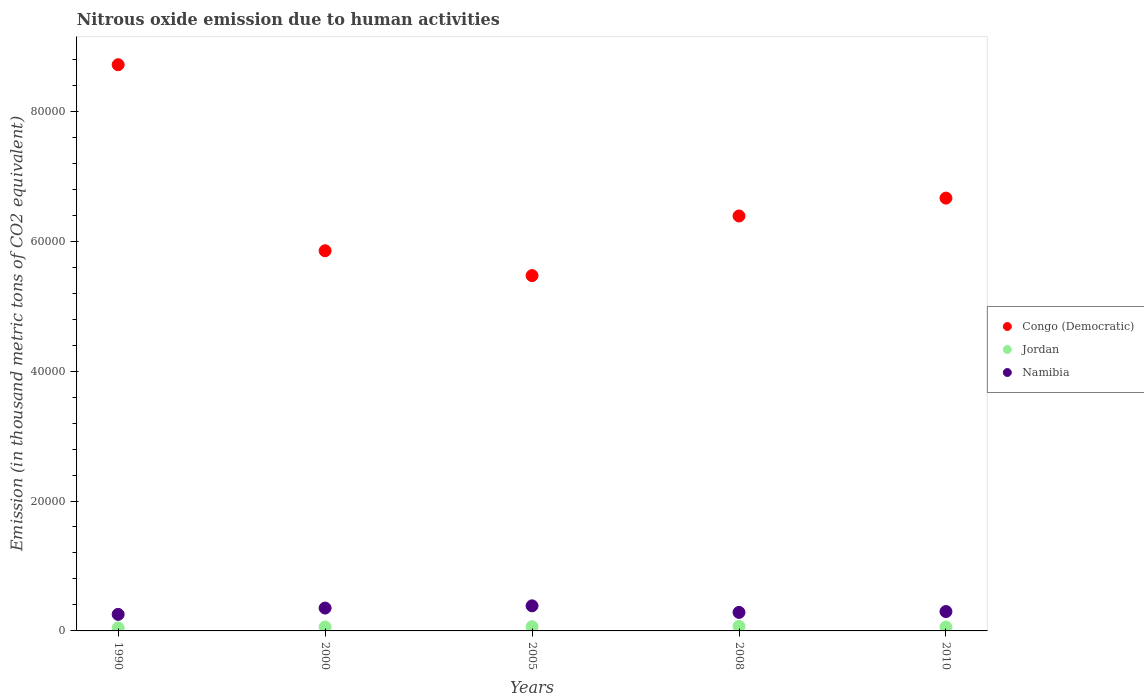Is the number of dotlines equal to the number of legend labels?
Offer a terse response. Yes. What is the amount of nitrous oxide emitted in Congo (Democratic) in 2008?
Ensure brevity in your answer.  6.39e+04. Across all years, what is the maximum amount of nitrous oxide emitted in Congo (Democratic)?
Offer a very short reply. 8.72e+04. Across all years, what is the minimum amount of nitrous oxide emitted in Namibia?
Offer a very short reply. 2547.1. In which year was the amount of nitrous oxide emitted in Namibia maximum?
Provide a short and direct response. 2005. In which year was the amount of nitrous oxide emitted in Congo (Democratic) minimum?
Offer a very short reply. 2005. What is the total amount of nitrous oxide emitted in Congo (Democratic) in the graph?
Offer a terse response. 3.31e+05. What is the difference between the amount of nitrous oxide emitted in Jordan in 1990 and that in 2008?
Offer a terse response. -231.1. What is the difference between the amount of nitrous oxide emitted in Namibia in 2008 and the amount of nitrous oxide emitted in Congo (Democratic) in 2010?
Offer a very short reply. -6.38e+04. What is the average amount of nitrous oxide emitted in Congo (Democratic) per year?
Give a very brief answer. 6.62e+04. In the year 2008, what is the difference between the amount of nitrous oxide emitted in Congo (Democratic) and amount of nitrous oxide emitted in Namibia?
Provide a short and direct response. 6.10e+04. What is the ratio of the amount of nitrous oxide emitted in Congo (Democratic) in 1990 to that in 2008?
Keep it short and to the point. 1.36. Is the amount of nitrous oxide emitted in Namibia in 2005 less than that in 2010?
Your response must be concise. No. Is the difference between the amount of nitrous oxide emitted in Congo (Democratic) in 1990 and 2000 greater than the difference between the amount of nitrous oxide emitted in Namibia in 1990 and 2000?
Your answer should be very brief. Yes. What is the difference between the highest and the second highest amount of nitrous oxide emitted in Jordan?
Ensure brevity in your answer.  43.9. What is the difference between the highest and the lowest amount of nitrous oxide emitted in Namibia?
Your answer should be very brief. 1314.1. In how many years, is the amount of nitrous oxide emitted in Congo (Democratic) greater than the average amount of nitrous oxide emitted in Congo (Democratic) taken over all years?
Your answer should be compact. 2. Is the sum of the amount of nitrous oxide emitted in Jordan in 2005 and 2010 greater than the maximum amount of nitrous oxide emitted in Namibia across all years?
Ensure brevity in your answer.  No. Does the amount of nitrous oxide emitted in Namibia monotonically increase over the years?
Keep it short and to the point. No. Is the amount of nitrous oxide emitted in Jordan strictly less than the amount of nitrous oxide emitted in Congo (Democratic) over the years?
Provide a short and direct response. Yes. How many dotlines are there?
Offer a very short reply. 3. How many years are there in the graph?
Ensure brevity in your answer.  5. What is the difference between two consecutive major ticks on the Y-axis?
Offer a very short reply. 2.00e+04. Does the graph contain any zero values?
Offer a very short reply. No. How many legend labels are there?
Provide a succinct answer. 3. How are the legend labels stacked?
Provide a succinct answer. Vertical. What is the title of the graph?
Make the answer very short. Nitrous oxide emission due to human activities. Does "Montenegro" appear as one of the legend labels in the graph?
Offer a terse response. No. What is the label or title of the X-axis?
Give a very brief answer. Years. What is the label or title of the Y-axis?
Offer a terse response. Emission (in thousand metric tons of CO2 equivalent). What is the Emission (in thousand metric tons of CO2 equivalent) in Congo (Democratic) in 1990?
Provide a short and direct response. 8.72e+04. What is the Emission (in thousand metric tons of CO2 equivalent) of Jordan in 1990?
Your answer should be compact. 463.8. What is the Emission (in thousand metric tons of CO2 equivalent) of Namibia in 1990?
Your answer should be compact. 2547.1. What is the Emission (in thousand metric tons of CO2 equivalent) in Congo (Democratic) in 2000?
Provide a succinct answer. 5.85e+04. What is the Emission (in thousand metric tons of CO2 equivalent) in Jordan in 2000?
Your answer should be very brief. 606.8. What is the Emission (in thousand metric tons of CO2 equivalent) of Namibia in 2000?
Offer a very short reply. 3518.5. What is the Emission (in thousand metric tons of CO2 equivalent) in Congo (Democratic) in 2005?
Ensure brevity in your answer.  5.47e+04. What is the Emission (in thousand metric tons of CO2 equivalent) in Jordan in 2005?
Make the answer very short. 651. What is the Emission (in thousand metric tons of CO2 equivalent) in Namibia in 2005?
Make the answer very short. 3861.2. What is the Emission (in thousand metric tons of CO2 equivalent) in Congo (Democratic) in 2008?
Your response must be concise. 6.39e+04. What is the Emission (in thousand metric tons of CO2 equivalent) of Jordan in 2008?
Your answer should be very brief. 694.9. What is the Emission (in thousand metric tons of CO2 equivalent) in Namibia in 2008?
Ensure brevity in your answer.  2851.2. What is the Emission (in thousand metric tons of CO2 equivalent) of Congo (Democratic) in 2010?
Your answer should be compact. 6.66e+04. What is the Emission (in thousand metric tons of CO2 equivalent) in Jordan in 2010?
Your response must be concise. 592.7. What is the Emission (in thousand metric tons of CO2 equivalent) of Namibia in 2010?
Make the answer very short. 2982.6. Across all years, what is the maximum Emission (in thousand metric tons of CO2 equivalent) in Congo (Democratic)?
Your answer should be compact. 8.72e+04. Across all years, what is the maximum Emission (in thousand metric tons of CO2 equivalent) in Jordan?
Give a very brief answer. 694.9. Across all years, what is the maximum Emission (in thousand metric tons of CO2 equivalent) in Namibia?
Provide a succinct answer. 3861.2. Across all years, what is the minimum Emission (in thousand metric tons of CO2 equivalent) of Congo (Democratic)?
Keep it short and to the point. 5.47e+04. Across all years, what is the minimum Emission (in thousand metric tons of CO2 equivalent) in Jordan?
Make the answer very short. 463.8. Across all years, what is the minimum Emission (in thousand metric tons of CO2 equivalent) in Namibia?
Ensure brevity in your answer.  2547.1. What is the total Emission (in thousand metric tons of CO2 equivalent) of Congo (Democratic) in the graph?
Offer a very short reply. 3.31e+05. What is the total Emission (in thousand metric tons of CO2 equivalent) in Jordan in the graph?
Your answer should be compact. 3009.2. What is the total Emission (in thousand metric tons of CO2 equivalent) in Namibia in the graph?
Offer a terse response. 1.58e+04. What is the difference between the Emission (in thousand metric tons of CO2 equivalent) of Congo (Democratic) in 1990 and that in 2000?
Offer a very short reply. 2.86e+04. What is the difference between the Emission (in thousand metric tons of CO2 equivalent) of Jordan in 1990 and that in 2000?
Your answer should be very brief. -143. What is the difference between the Emission (in thousand metric tons of CO2 equivalent) in Namibia in 1990 and that in 2000?
Offer a very short reply. -971.4. What is the difference between the Emission (in thousand metric tons of CO2 equivalent) of Congo (Democratic) in 1990 and that in 2005?
Provide a succinct answer. 3.25e+04. What is the difference between the Emission (in thousand metric tons of CO2 equivalent) in Jordan in 1990 and that in 2005?
Offer a very short reply. -187.2. What is the difference between the Emission (in thousand metric tons of CO2 equivalent) in Namibia in 1990 and that in 2005?
Your answer should be very brief. -1314.1. What is the difference between the Emission (in thousand metric tons of CO2 equivalent) of Congo (Democratic) in 1990 and that in 2008?
Ensure brevity in your answer.  2.33e+04. What is the difference between the Emission (in thousand metric tons of CO2 equivalent) of Jordan in 1990 and that in 2008?
Keep it short and to the point. -231.1. What is the difference between the Emission (in thousand metric tons of CO2 equivalent) of Namibia in 1990 and that in 2008?
Give a very brief answer. -304.1. What is the difference between the Emission (in thousand metric tons of CO2 equivalent) of Congo (Democratic) in 1990 and that in 2010?
Your answer should be compact. 2.05e+04. What is the difference between the Emission (in thousand metric tons of CO2 equivalent) in Jordan in 1990 and that in 2010?
Your response must be concise. -128.9. What is the difference between the Emission (in thousand metric tons of CO2 equivalent) of Namibia in 1990 and that in 2010?
Give a very brief answer. -435.5. What is the difference between the Emission (in thousand metric tons of CO2 equivalent) of Congo (Democratic) in 2000 and that in 2005?
Ensure brevity in your answer.  3826.5. What is the difference between the Emission (in thousand metric tons of CO2 equivalent) in Jordan in 2000 and that in 2005?
Make the answer very short. -44.2. What is the difference between the Emission (in thousand metric tons of CO2 equivalent) in Namibia in 2000 and that in 2005?
Provide a short and direct response. -342.7. What is the difference between the Emission (in thousand metric tons of CO2 equivalent) in Congo (Democratic) in 2000 and that in 2008?
Your response must be concise. -5353.8. What is the difference between the Emission (in thousand metric tons of CO2 equivalent) in Jordan in 2000 and that in 2008?
Provide a short and direct response. -88.1. What is the difference between the Emission (in thousand metric tons of CO2 equivalent) of Namibia in 2000 and that in 2008?
Provide a short and direct response. 667.3. What is the difference between the Emission (in thousand metric tons of CO2 equivalent) in Congo (Democratic) in 2000 and that in 2010?
Make the answer very short. -8104.1. What is the difference between the Emission (in thousand metric tons of CO2 equivalent) of Jordan in 2000 and that in 2010?
Ensure brevity in your answer.  14.1. What is the difference between the Emission (in thousand metric tons of CO2 equivalent) in Namibia in 2000 and that in 2010?
Offer a terse response. 535.9. What is the difference between the Emission (in thousand metric tons of CO2 equivalent) in Congo (Democratic) in 2005 and that in 2008?
Your response must be concise. -9180.3. What is the difference between the Emission (in thousand metric tons of CO2 equivalent) of Jordan in 2005 and that in 2008?
Ensure brevity in your answer.  -43.9. What is the difference between the Emission (in thousand metric tons of CO2 equivalent) of Namibia in 2005 and that in 2008?
Your answer should be compact. 1010. What is the difference between the Emission (in thousand metric tons of CO2 equivalent) of Congo (Democratic) in 2005 and that in 2010?
Keep it short and to the point. -1.19e+04. What is the difference between the Emission (in thousand metric tons of CO2 equivalent) in Jordan in 2005 and that in 2010?
Ensure brevity in your answer.  58.3. What is the difference between the Emission (in thousand metric tons of CO2 equivalent) in Namibia in 2005 and that in 2010?
Provide a succinct answer. 878.6. What is the difference between the Emission (in thousand metric tons of CO2 equivalent) in Congo (Democratic) in 2008 and that in 2010?
Provide a short and direct response. -2750.3. What is the difference between the Emission (in thousand metric tons of CO2 equivalent) in Jordan in 2008 and that in 2010?
Your answer should be compact. 102.2. What is the difference between the Emission (in thousand metric tons of CO2 equivalent) of Namibia in 2008 and that in 2010?
Your response must be concise. -131.4. What is the difference between the Emission (in thousand metric tons of CO2 equivalent) in Congo (Democratic) in 1990 and the Emission (in thousand metric tons of CO2 equivalent) in Jordan in 2000?
Your answer should be compact. 8.66e+04. What is the difference between the Emission (in thousand metric tons of CO2 equivalent) in Congo (Democratic) in 1990 and the Emission (in thousand metric tons of CO2 equivalent) in Namibia in 2000?
Ensure brevity in your answer.  8.36e+04. What is the difference between the Emission (in thousand metric tons of CO2 equivalent) of Jordan in 1990 and the Emission (in thousand metric tons of CO2 equivalent) of Namibia in 2000?
Make the answer very short. -3054.7. What is the difference between the Emission (in thousand metric tons of CO2 equivalent) in Congo (Democratic) in 1990 and the Emission (in thousand metric tons of CO2 equivalent) in Jordan in 2005?
Your answer should be very brief. 8.65e+04. What is the difference between the Emission (in thousand metric tons of CO2 equivalent) of Congo (Democratic) in 1990 and the Emission (in thousand metric tons of CO2 equivalent) of Namibia in 2005?
Ensure brevity in your answer.  8.33e+04. What is the difference between the Emission (in thousand metric tons of CO2 equivalent) in Jordan in 1990 and the Emission (in thousand metric tons of CO2 equivalent) in Namibia in 2005?
Offer a terse response. -3397.4. What is the difference between the Emission (in thousand metric tons of CO2 equivalent) in Congo (Democratic) in 1990 and the Emission (in thousand metric tons of CO2 equivalent) in Jordan in 2008?
Give a very brief answer. 8.65e+04. What is the difference between the Emission (in thousand metric tons of CO2 equivalent) of Congo (Democratic) in 1990 and the Emission (in thousand metric tons of CO2 equivalent) of Namibia in 2008?
Your answer should be very brief. 8.43e+04. What is the difference between the Emission (in thousand metric tons of CO2 equivalent) of Jordan in 1990 and the Emission (in thousand metric tons of CO2 equivalent) of Namibia in 2008?
Keep it short and to the point. -2387.4. What is the difference between the Emission (in thousand metric tons of CO2 equivalent) of Congo (Democratic) in 1990 and the Emission (in thousand metric tons of CO2 equivalent) of Jordan in 2010?
Offer a very short reply. 8.66e+04. What is the difference between the Emission (in thousand metric tons of CO2 equivalent) of Congo (Democratic) in 1990 and the Emission (in thousand metric tons of CO2 equivalent) of Namibia in 2010?
Your answer should be very brief. 8.42e+04. What is the difference between the Emission (in thousand metric tons of CO2 equivalent) of Jordan in 1990 and the Emission (in thousand metric tons of CO2 equivalent) of Namibia in 2010?
Make the answer very short. -2518.8. What is the difference between the Emission (in thousand metric tons of CO2 equivalent) of Congo (Democratic) in 2000 and the Emission (in thousand metric tons of CO2 equivalent) of Jordan in 2005?
Offer a terse response. 5.79e+04. What is the difference between the Emission (in thousand metric tons of CO2 equivalent) in Congo (Democratic) in 2000 and the Emission (in thousand metric tons of CO2 equivalent) in Namibia in 2005?
Provide a short and direct response. 5.47e+04. What is the difference between the Emission (in thousand metric tons of CO2 equivalent) of Jordan in 2000 and the Emission (in thousand metric tons of CO2 equivalent) of Namibia in 2005?
Your answer should be very brief. -3254.4. What is the difference between the Emission (in thousand metric tons of CO2 equivalent) in Congo (Democratic) in 2000 and the Emission (in thousand metric tons of CO2 equivalent) in Jordan in 2008?
Ensure brevity in your answer.  5.78e+04. What is the difference between the Emission (in thousand metric tons of CO2 equivalent) of Congo (Democratic) in 2000 and the Emission (in thousand metric tons of CO2 equivalent) of Namibia in 2008?
Ensure brevity in your answer.  5.57e+04. What is the difference between the Emission (in thousand metric tons of CO2 equivalent) of Jordan in 2000 and the Emission (in thousand metric tons of CO2 equivalent) of Namibia in 2008?
Your response must be concise. -2244.4. What is the difference between the Emission (in thousand metric tons of CO2 equivalent) of Congo (Democratic) in 2000 and the Emission (in thousand metric tons of CO2 equivalent) of Jordan in 2010?
Your response must be concise. 5.79e+04. What is the difference between the Emission (in thousand metric tons of CO2 equivalent) of Congo (Democratic) in 2000 and the Emission (in thousand metric tons of CO2 equivalent) of Namibia in 2010?
Ensure brevity in your answer.  5.55e+04. What is the difference between the Emission (in thousand metric tons of CO2 equivalent) of Jordan in 2000 and the Emission (in thousand metric tons of CO2 equivalent) of Namibia in 2010?
Your answer should be very brief. -2375.8. What is the difference between the Emission (in thousand metric tons of CO2 equivalent) in Congo (Democratic) in 2005 and the Emission (in thousand metric tons of CO2 equivalent) in Jordan in 2008?
Ensure brevity in your answer.  5.40e+04. What is the difference between the Emission (in thousand metric tons of CO2 equivalent) of Congo (Democratic) in 2005 and the Emission (in thousand metric tons of CO2 equivalent) of Namibia in 2008?
Keep it short and to the point. 5.19e+04. What is the difference between the Emission (in thousand metric tons of CO2 equivalent) in Jordan in 2005 and the Emission (in thousand metric tons of CO2 equivalent) in Namibia in 2008?
Make the answer very short. -2200.2. What is the difference between the Emission (in thousand metric tons of CO2 equivalent) in Congo (Democratic) in 2005 and the Emission (in thousand metric tons of CO2 equivalent) in Jordan in 2010?
Give a very brief answer. 5.41e+04. What is the difference between the Emission (in thousand metric tons of CO2 equivalent) of Congo (Democratic) in 2005 and the Emission (in thousand metric tons of CO2 equivalent) of Namibia in 2010?
Your answer should be very brief. 5.17e+04. What is the difference between the Emission (in thousand metric tons of CO2 equivalent) of Jordan in 2005 and the Emission (in thousand metric tons of CO2 equivalent) of Namibia in 2010?
Keep it short and to the point. -2331.6. What is the difference between the Emission (in thousand metric tons of CO2 equivalent) of Congo (Democratic) in 2008 and the Emission (in thousand metric tons of CO2 equivalent) of Jordan in 2010?
Your response must be concise. 6.33e+04. What is the difference between the Emission (in thousand metric tons of CO2 equivalent) in Congo (Democratic) in 2008 and the Emission (in thousand metric tons of CO2 equivalent) in Namibia in 2010?
Offer a terse response. 6.09e+04. What is the difference between the Emission (in thousand metric tons of CO2 equivalent) of Jordan in 2008 and the Emission (in thousand metric tons of CO2 equivalent) of Namibia in 2010?
Make the answer very short. -2287.7. What is the average Emission (in thousand metric tons of CO2 equivalent) of Congo (Democratic) per year?
Provide a short and direct response. 6.62e+04. What is the average Emission (in thousand metric tons of CO2 equivalent) of Jordan per year?
Your response must be concise. 601.84. What is the average Emission (in thousand metric tons of CO2 equivalent) of Namibia per year?
Provide a succinct answer. 3152.12. In the year 1990, what is the difference between the Emission (in thousand metric tons of CO2 equivalent) in Congo (Democratic) and Emission (in thousand metric tons of CO2 equivalent) in Jordan?
Your response must be concise. 8.67e+04. In the year 1990, what is the difference between the Emission (in thousand metric tons of CO2 equivalent) in Congo (Democratic) and Emission (in thousand metric tons of CO2 equivalent) in Namibia?
Keep it short and to the point. 8.46e+04. In the year 1990, what is the difference between the Emission (in thousand metric tons of CO2 equivalent) of Jordan and Emission (in thousand metric tons of CO2 equivalent) of Namibia?
Your answer should be compact. -2083.3. In the year 2000, what is the difference between the Emission (in thousand metric tons of CO2 equivalent) in Congo (Democratic) and Emission (in thousand metric tons of CO2 equivalent) in Jordan?
Offer a terse response. 5.79e+04. In the year 2000, what is the difference between the Emission (in thousand metric tons of CO2 equivalent) of Congo (Democratic) and Emission (in thousand metric tons of CO2 equivalent) of Namibia?
Ensure brevity in your answer.  5.50e+04. In the year 2000, what is the difference between the Emission (in thousand metric tons of CO2 equivalent) of Jordan and Emission (in thousand metric tons of CO2 equivalent) of Namibia?
Your answer should be very brief. -2911.7. In the year 2005, what is the difference between the Emission (in thousand metric tons of CO2 equivalent) of Congo (Democratic) and Emission (in thousand metric tons of CO2 equivalent) of Jordan?
Your answer should be compact. 5.41e+04. In the year 2005, what is the difference between the Emission (in thousand metric tons of CO2 equivalent) of Congo (Democratic) and Emission (in thousand metric tons of CO2 equivalent) of Namibia?
Your response must be concise. 5.08e+04. In the year 2005, what is the difference between the Emission (in thousand metric tons of CO2 equivalent) in Jordan and Emission (in thousand metric tons of CO2 equivalent) in Namibia?
Keep it short and to the point. -3210.2. In the year 2008, what is the difference between the Emission (in thousand metric tons of CO2 equivalent) of Congo (Democratic) and Emission (in thousand metric tons of CO2 equivalent) of Jordan?
Your answer should be compact. 6.32e+04. In the year 2008, what is the difference between the Emission (in thousand metric tons of CO2 equivalent) in Congo (Democratic) and Emission (in thousand metric tons of CO2 equivalent) in Namibia?
Make the answer very short. 6.10e+04. In the year 2008, what is the difference between the Emission (in thousand metric tons of CO2 equivalent) in Jordan and Emission (in thousand metric tons of CO2 equivalent) in Namibia?
Your response must be concise. -2156.3. In the year 2010, what is the difference between the Emission (in thousand metric tons of CO2 equivalent) of Congo (Democratic) and Emission (in thousand metric tons of CO2 equivalent) of Jordan?
Your answer should be compact. 6.60e+04. In the year 2010, what is the difference between the Emission (in thousand metric tons of CO2 equivalent) in Congo (Democratic) and Emission (in thousand metric tons of CO2 equivalent) in Namibia?
Make the answer very short. 6.36e+04. In the year 2010, what is the difference between the Emission (in thousand metric tons of CO2 equivalent) of Jordan and Emission (in thousand metric tons of CO2 equivalent) of Namibia?
Make the answer very short. -2389.9. What is the ratio of the Emission (in thousand metric tons of CO2 equivalent) in Congo (Democratic) in 1990 to that in 2000?
Offer a terse response. 1.49. What is the ratio of the Emission (in thousand metric tons of CO2 equivalent) of Jordan in 1990 to that in 2000?
Provide a succinct answer. 0.76. What is the ratio of the Emission (in thousand metric tons of CO2 equivalent) of Namibia in 1990 to that in 2000?
Your response must be concise. 0.72. What is the ratio of the Emission (in thousand metric tons of CO2 equivalent) in Congo (Democratic) in 1990 to that in 2005?
Provide a short and direct response. 1.59. What is the ratio of the Emission (in thousand metric tons of CO2 equivalent) in Jordan in 1990 to that in 2005?
Ensure brevity in your answer.  0.71. What is the ratio of the Emission (in thousand metric tons of CO2 equivalent) of Namibia in 1990 to that in 2005?
Your answer should be very brief. 0.66. What is the ratio of the Emission (in thousand metric tons of CO2 equivalent) of Congo (Democratic) in 1990 to that in 2008?
Offer a terse response. 1.36. What is the ratio of the Emission (in thousand metric tons of CO2 equivalent) in Jordan in 1990 to that in 2008?
Your answer should be very brief. 0.67. What is the ratio of the Emission (in thousand metric tons of CO2 equivalent) in Namibia in 1990 to that in 2008?
Offer a terse response. 0.89. What is the ratio of the Emission (in thousand metric tons of CO2 equivalent) of Congo (Democratic) in 1990 to that in 2010?
Your response must be concise. 1.31. What is the ratio of the Emission (in thousand metric tons of CO2 equivalent) of Jordan in 1990 to that in 2010?
Your answer should be compact. 0.78. What is the ratio of the Emission (in thousand metric tons of CO2 equivalent) of Namibia in 1990 to that in 2010?
Keep it short and to the point. 0.85. What is the ratio of the Emission (in thousand metric tons of CO2 equivalent) in Congo (Democratic) in 2000 to that in 2005?
Offer a terse response. 1.07. What is the ratio of the Emission (in thousand metric tons of CO2 equivalent) in Jordan in 2000 to that in 2005?
Provide a succinct answer. 0.93. What is the ratio of the Emission (in thousand metric tons of CO2 equivalent) of Namibia in 2000 to that in 2005?
Ensure brevity in your answer.  0.91. What is the ratio of the Emission (in thousand metric tons of CO2 equivalent) in Congo (Democratic) in 2000 to that in 2008?
Make the answer very short. 0.92. What is the ratio of the Emission (in thousand metric tons of CO2 equivalent) in Jordan in 2000 to that in 2008?
Provide a short and direct response. 0.87. What is the ratio of the Emission (in thousand metric tons of CO2 equivalent) in Namibia in 2000 to that in 2008?
Give a very brief answer. 1.23. What is the ratio of the Emission (in thousand metric tons of CO2 equivalent) of Congo (Democratic) in 2000 to that in 2010?
Ensure brevity in your answer.  0.88. What is the ratio of the Emission (in thousand metric tons of CO2 equivalent) in Jordan in 2000 to that in 2010?
Provide a short and direct response. 1.02. What is the ratio of the Emission (in thousand metric tons of CO2 equivalent) of Namibia in 2000 to that in 2010?
Make the answer very short. 1.18. What is the ratio of the Emission (in thousand metric tons of CO2 equivalent) of Congo (Democratic) in 2005 to that in 2008?
Offer a very short reply. 0.86. What is the ratio of the Emission (in thousand metric tons of CO2 equivalent) of Jordan in 2005 to that in 2008?
Your response must be concise. 0.94. What is the ratio of the Emission (in thousand metric tons of CO2 equivalent) in Namibia in 2005 to that in 2008?
Your answer should be very brief. 1.35. What is the ratio of the Emission (in thousand metric tons of CO2 equivalent) in Congo (Democratic) in 2005 to that in 2010?
Your answer should be very brief. 0.82. What is the ratio of the Emission (in thousand metric tons of CO2 equivalent) in Jordan in 2005 to that in 2010?
Provide a short and direct response. 1.1. What is the ratio of the Emission (in thousand metric tons of CO2 equivalent) in Namibia in 2005 to that in 2010?
Provide a succinct answer. 1.29. What is the ratio of the Emission (in thousand metric tons of CO2 equivalent) in Congo (Democratic) in 2008 to that in 2010?
Make the answer very short. 0.96. What is the ratio of the Emission (in thousand metric tons of CO2 equivalent) in Jordan in 2008 to that in 2010?
Give a very brief answer. 1.17. What is the ratio of the Emission (in thousand metric tons of CO2 equivalent) of Namibia in 2008 to that in 2010?
Your answer should be very brief. 0.96. What is the difference between the highest and the second highest Emission (in thousand metric tons of CO2 equivalent) of Congo (Democratic)?
Offer a very short reply. 2.05e+04. What is the difference between the highest and the second highest Emission (in thousand metric tons of CO2 equivalent) of Jordan?
Keep it short and to the point. 43.9. What is the difference between the highest and the second highest Emission (in thousand metric tons of CO2 equivalent) in Namibia?
Keep it short and to the point. 342.7. What is the difference between the highest and the lowest Emission (in thousand metric tons of CO2 equivalent) in Congo (Democratic)?
Your response must be concise. 3.25e+04. What is the difference between the highest and the lowest Emission (in thousand metric tons of CO2 equivalent) in Jordan?
Offer a terse response. 231.1. What is the difference between the highest and the lowest Emission (in thousand metric tons of CO2 equivalent) of Namibia?
Offer a terse response. 1314.1. 